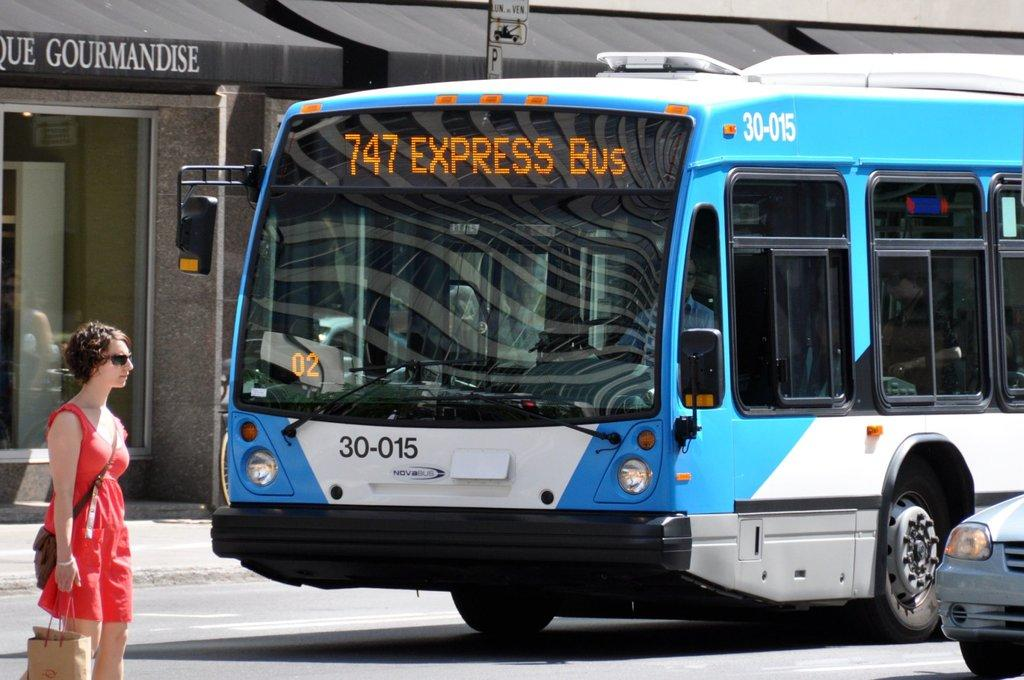Who is present in the image? There is a woman in the image. What is the woman holding or carrying? There are bags in the image, which suggests that the woman might be holding or carrying them. What can be seen in the background of the image? There are vehicles on the road in the image. Can you describe any other objects or features in the image? There are some unspecified objects in the image. What type of acoustics can be heard in the image? There is no information about any sounds or acoustics in the image, so it cannot be determined from the image alone. 